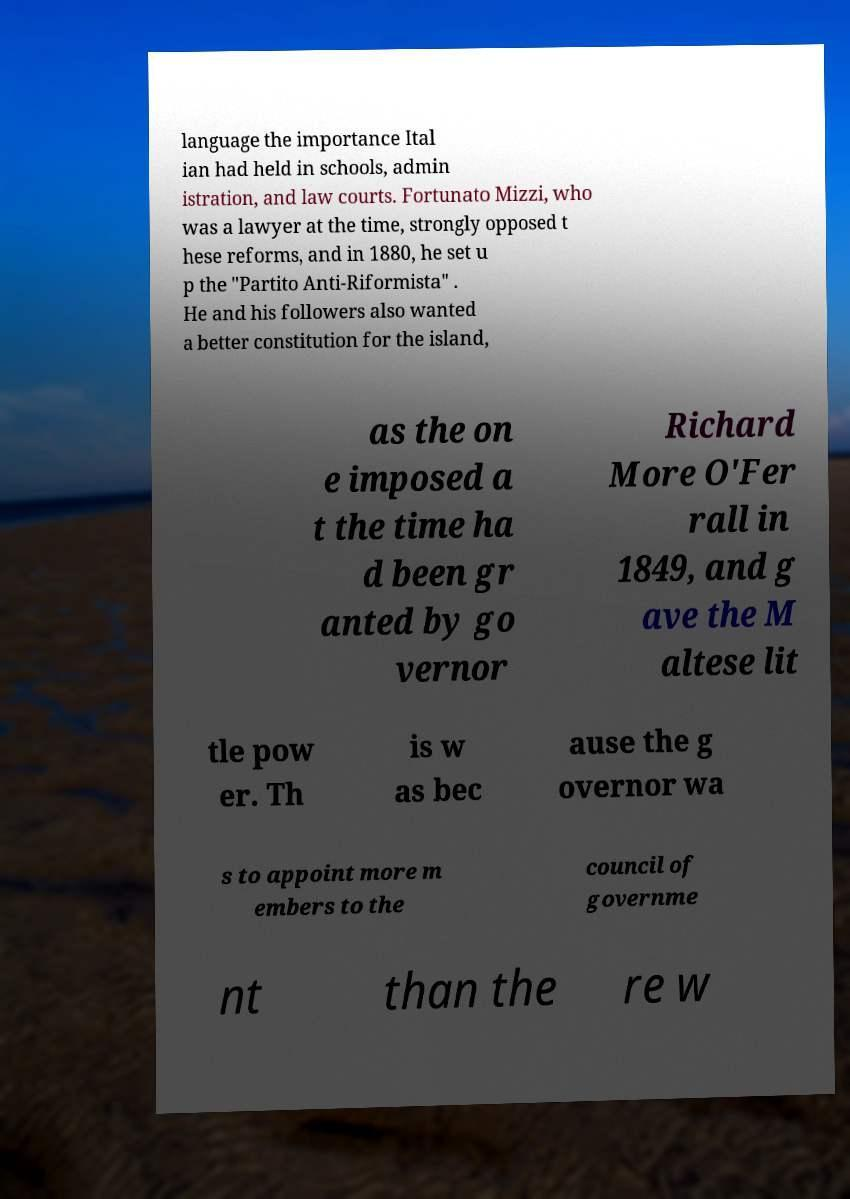Can you read and provide the text displayed in the image?This photo seems to have some interesting text. Can you extract and type it out for me? language the importance Ital ian had held in schools, admin istration, and law courts. Fortunato Mizzi, who was a lawyer at the time, strongly opposed t hese reforms, and in 1880, he set u p the "Partito Anti-Riformista" . He and his followers also wanted a better constitution for the island, as the on e imposed a t the time ha d been gr anted by go vernor Richard More O'Fer rall in 1849, and g ave the M altese lit tle pow er. Th is w as bec ause the g overnor wa s to appoint more m embers to the council of governme nt than the re w 